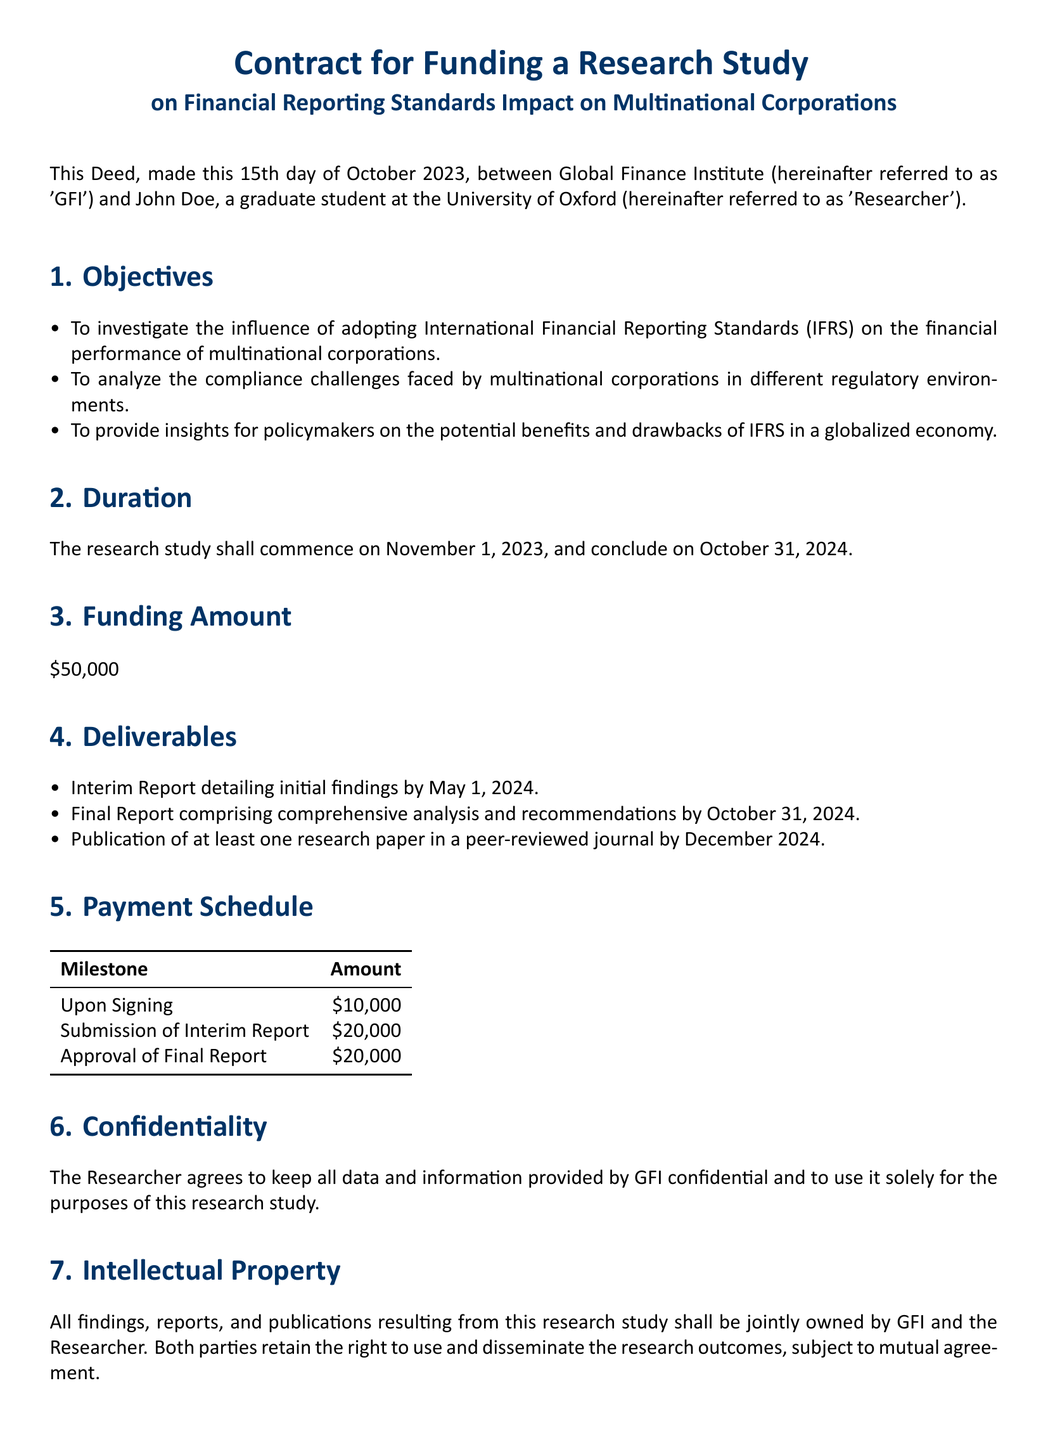What is the date of the deed? The deed is dated the 15th day of October 2023 as stated in the introduction.
Answer: October 15, 2023 Who is the researcher? The researcher is identified as John Doe, a graduate student at the University of Oxford.
Answer: John Doe What is the funding amount? The document specifies the total funding amount as $50,000.
Answer: $50,000 When is the interim report due? The interim report is due by May 1, 2024, as outlined in the deliverables section.
Answer: May 1, 2024 What is the payment amount upon signing? According to the payment schedule, the amount upon signing is $10,000.
Answer: $10,000 What happens if the deed is terminated? The deed states that in the event of termination, unspent funds must be returned to GFI.
Answer: Return unspent funds What is the ownership of the research outcomes? The intellectual property clause states that all findings are jointly owned by GFI and the researcher.
Answer: Jointly owned How long is the duration of the research study? The duration of the study is from November 1, 2023, to October 31, 2024.
Answer: 1 year What is the purpose of the study? The objectives section outlines the purpose as investigating the influence of IFRS on financial performance.
Answer: Investigate IFRS influence 